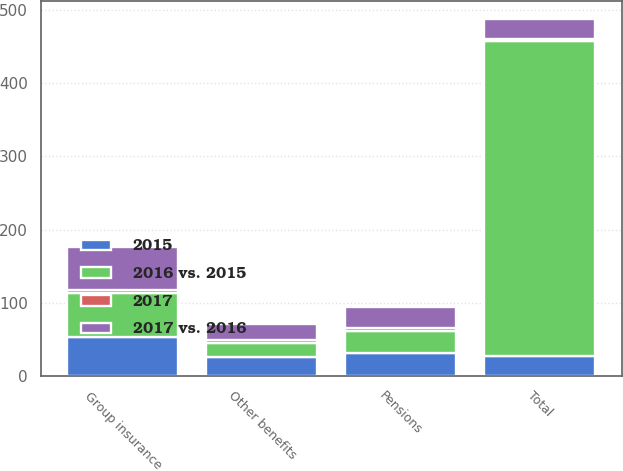Convert chart. <chart><loc_0><loc_0><loc_500><loc_500><stacked_bar_chart><ecel><fcel>Pensions<fcel>Group insurance<fcel>Other benefits<fcel>Total<nl><fcel>2015<fcel>32<fcel>54<fcel>26<fcel>27<nl><fcel>2017 vs. 2016<fcel>28<fcel>58<fcel>21<fcel>27<nl><fcel>2016 vs. 2015<fcel>30<fcel>60<fcel>19<fcel>430<nl><fcel>2017<fcel>4<fcel>4<fcel>5<fcel>3<nl></chart> 